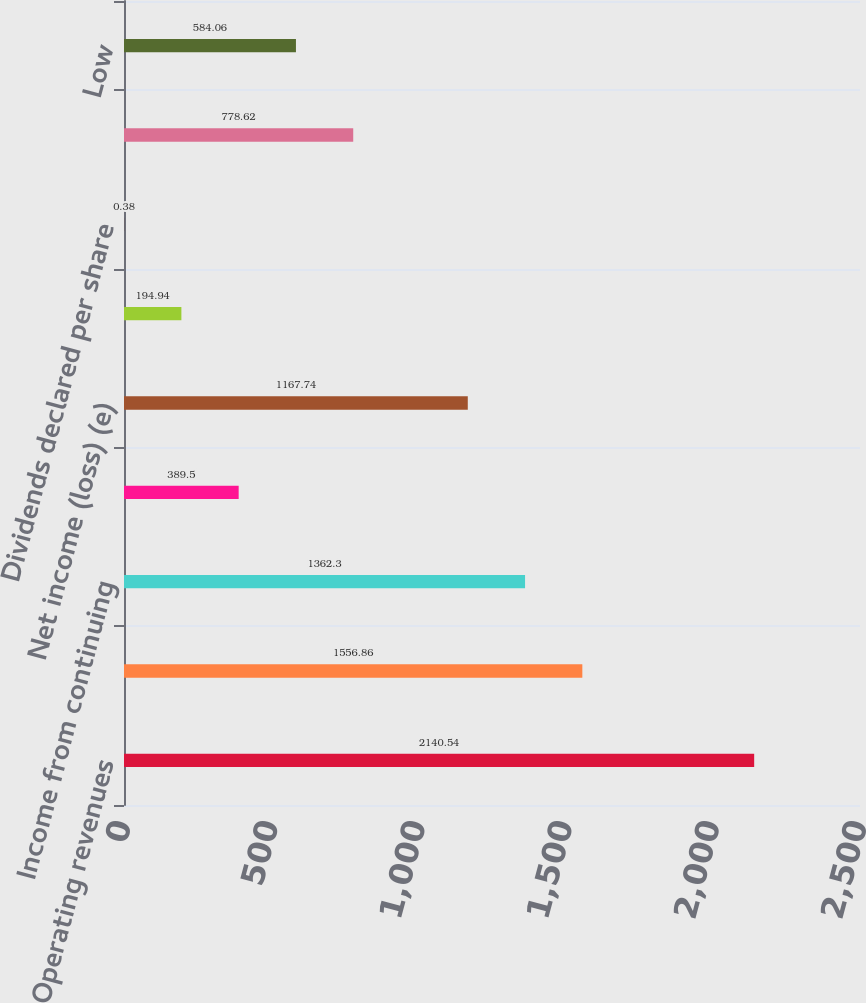Convert chart. <chart><loc_0><loc_0><loc_500><loc_500><bar_chart><fcel>Operating revenues<fcel>Operating income<fcel>Income from continuing<fcel>Income (loss) from<fcel>Net income (loss) (e)<fcel>Basic EPS<fcel>Dividends declared per share<fcel>High<fcel>Low<nl><fcel>2140.54<fcel>1556.86<fcel>1362.3<fcel>389.5<fcel>1167.74<fcel>194.94<fcel>0.38<fcel>778.62<fcel>584.06<nl></chart> 